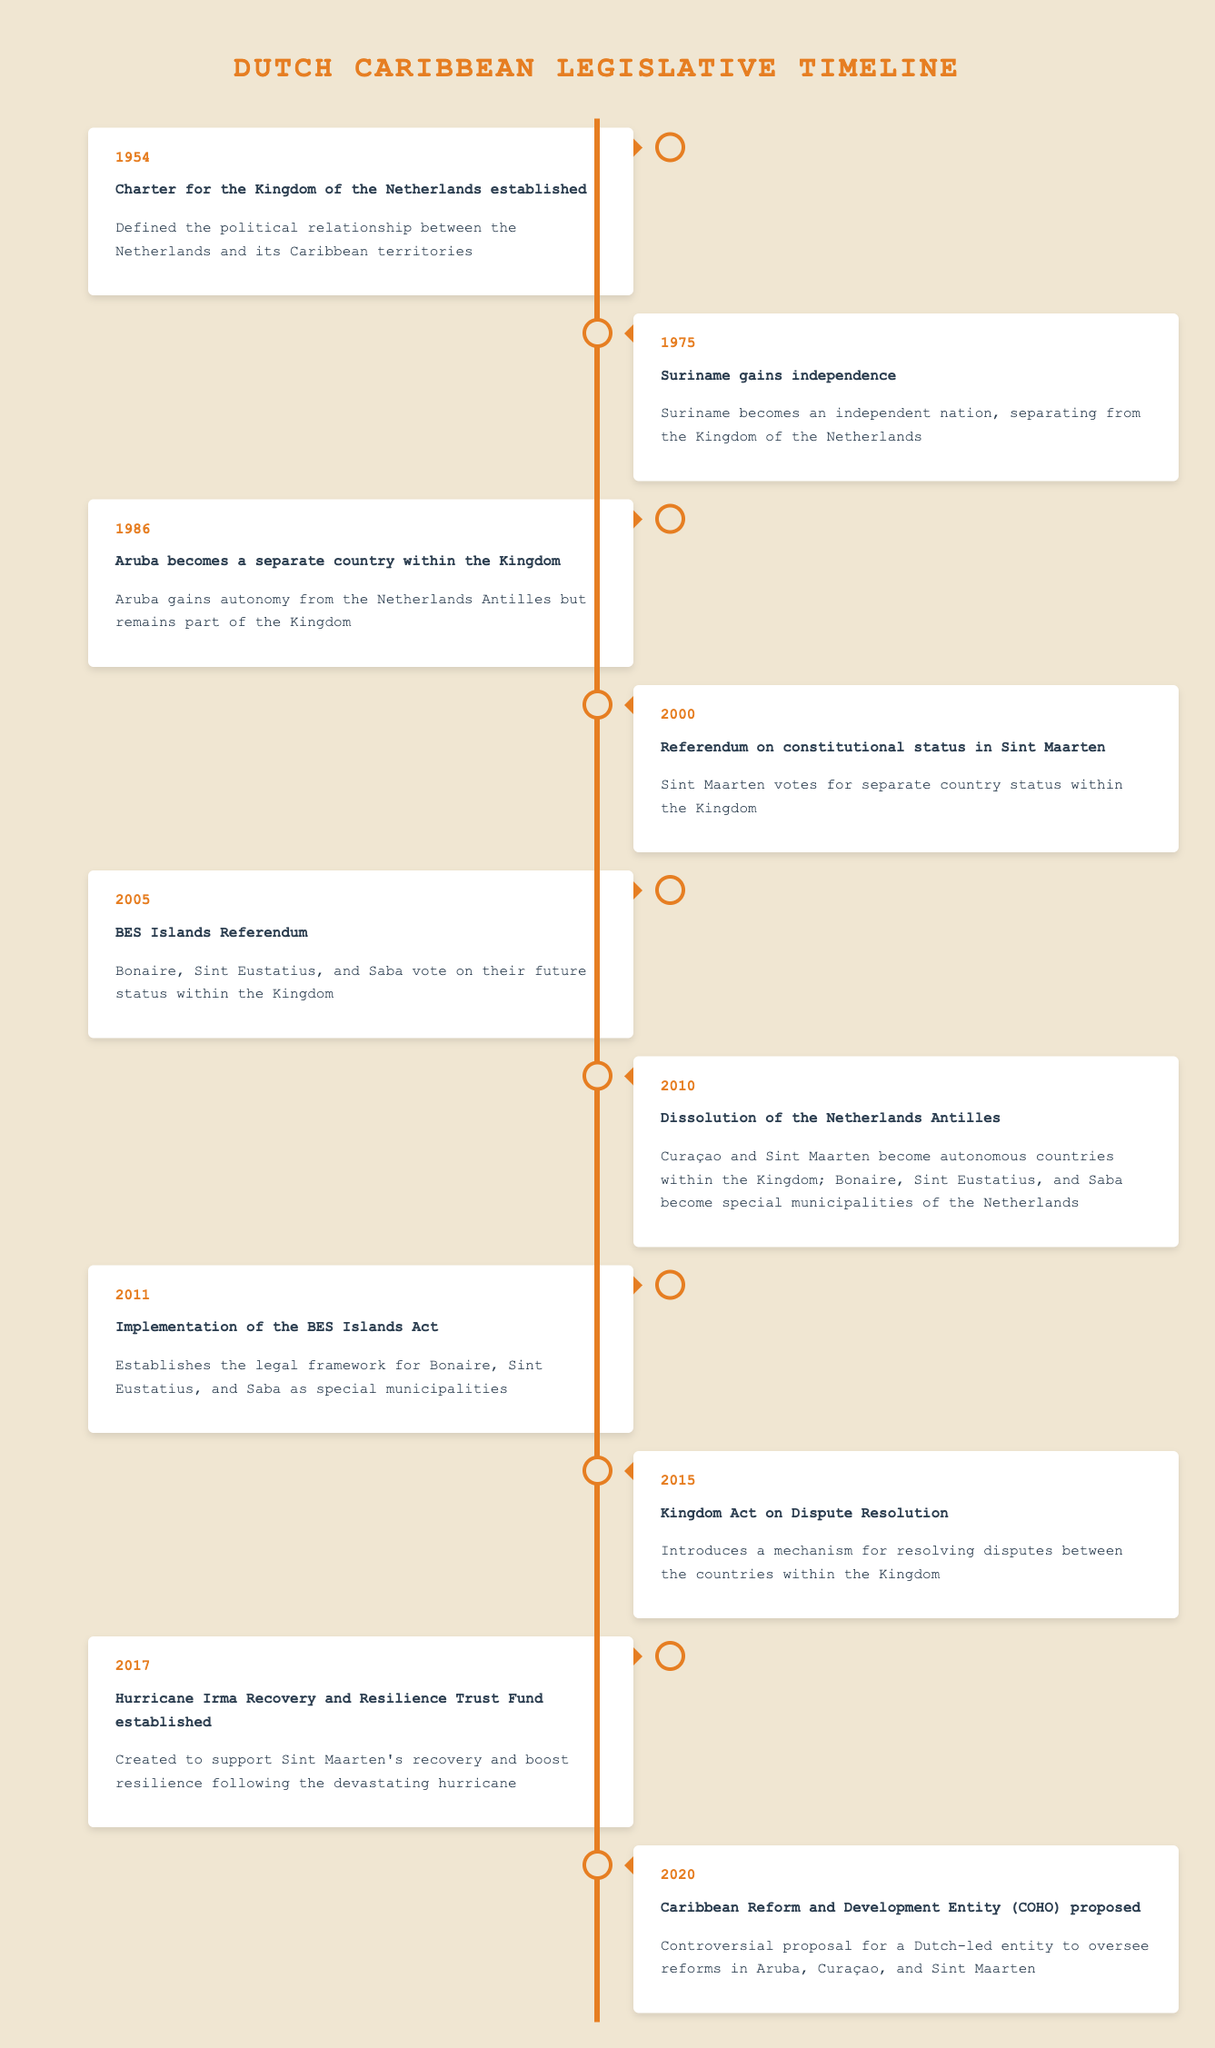What year was the Charter for the Kingdom of the Netherlands established? The table shows that the event "Charter for the Kingdom of the Netherlands established" occurred in 1954.
Answer: 1954 Which event marked the independence of Suriname? According to the table, Suriname gained independence in 1975, which is explicitly stated next to the event.
Answer: Suriname gains independence True or False: Aruba gained autonomy from the Netherlands Antilles. The description for the year 1986 states that Aruba gained autonomy from the Netherlands Antilles but remained part of the Kingdom, confirming the fact as true.
Answer: True In what year did Sint Maarten vote for separate country status within the Kingdom? The table indicates that the referendum on constitutional status in Sint Maarten took place in 2000, leading to its vote for separate country status.
Answer: 2000 What are the years in which significant referendums took place? The table mentions two referendums: one in 2000 for Sint Maarten and another in 2005 for the BES Islands. Therefore, the years of significant referendums are 2000 and 2005.
Answer: 2000 and 2005 What is the average year of legislative changes from 1954 to 2020? The relevant years in the table for legislative change are 1954, 1975, 1986, 2000, 2005, 2010, 2011, 2015, 2017, and 2020 (10 years). To find the average, sum them up: 1954 + 1975 + 1986 + 2000 + 2005 + 2010 + 2011 + 2015 + 2017 + 2020 = 19873; then divide by 10, giving 1987.3, approximately 1987.
Answer: 1987 What event occurred before the dissolution of the Netherlands Antilles? The table indicates that the BES Islands Referendum took place in 2005 and the Netherlands Antilles dissolved in 2010. Therefore, the BES Islands Referendum is the event that occurred before the dissolution.
Answer: BES Islands Referendum How many years between the establishment of the Charter and the gain of independence by Suriname? The Charter was established in 1954 and Suriname gained independence in 1975. To find the difference, subtract 1954 from 1975, resulting in a difference of 21 years.
Answer: 21 Which events occurred after 2015? According to the table, the events that occurred after 2015 are the establishment of the Hurricane Irma Recovery Fund in 2017 and the proposal of the Caribbean Reform and Development Entity in 2020.
Answer: Hurricane Irma Recovery Fund and Caribbean Reform and Development Entity 